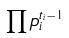Convert formula to latex. <formula><loc_0><loc_0><loc_500><loc_500>\prod p _ { i } ^ { t _ { i } - 1 }</formula> 